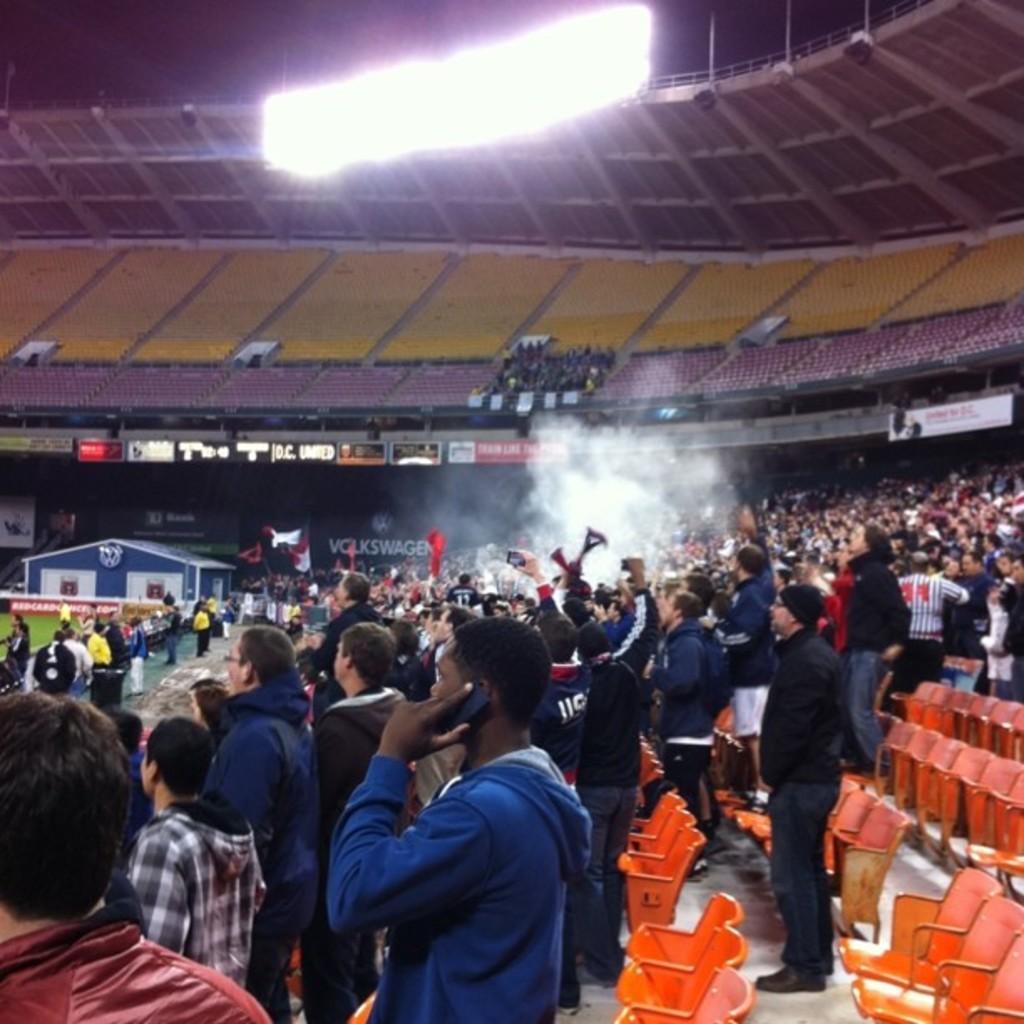Please provide a concise description of this image. The image is taken in a stadium. In the foreground of the picture there are people, flag, smoke and chairs. In the background there are chairs, hoardings. At the top there are flood lights. 